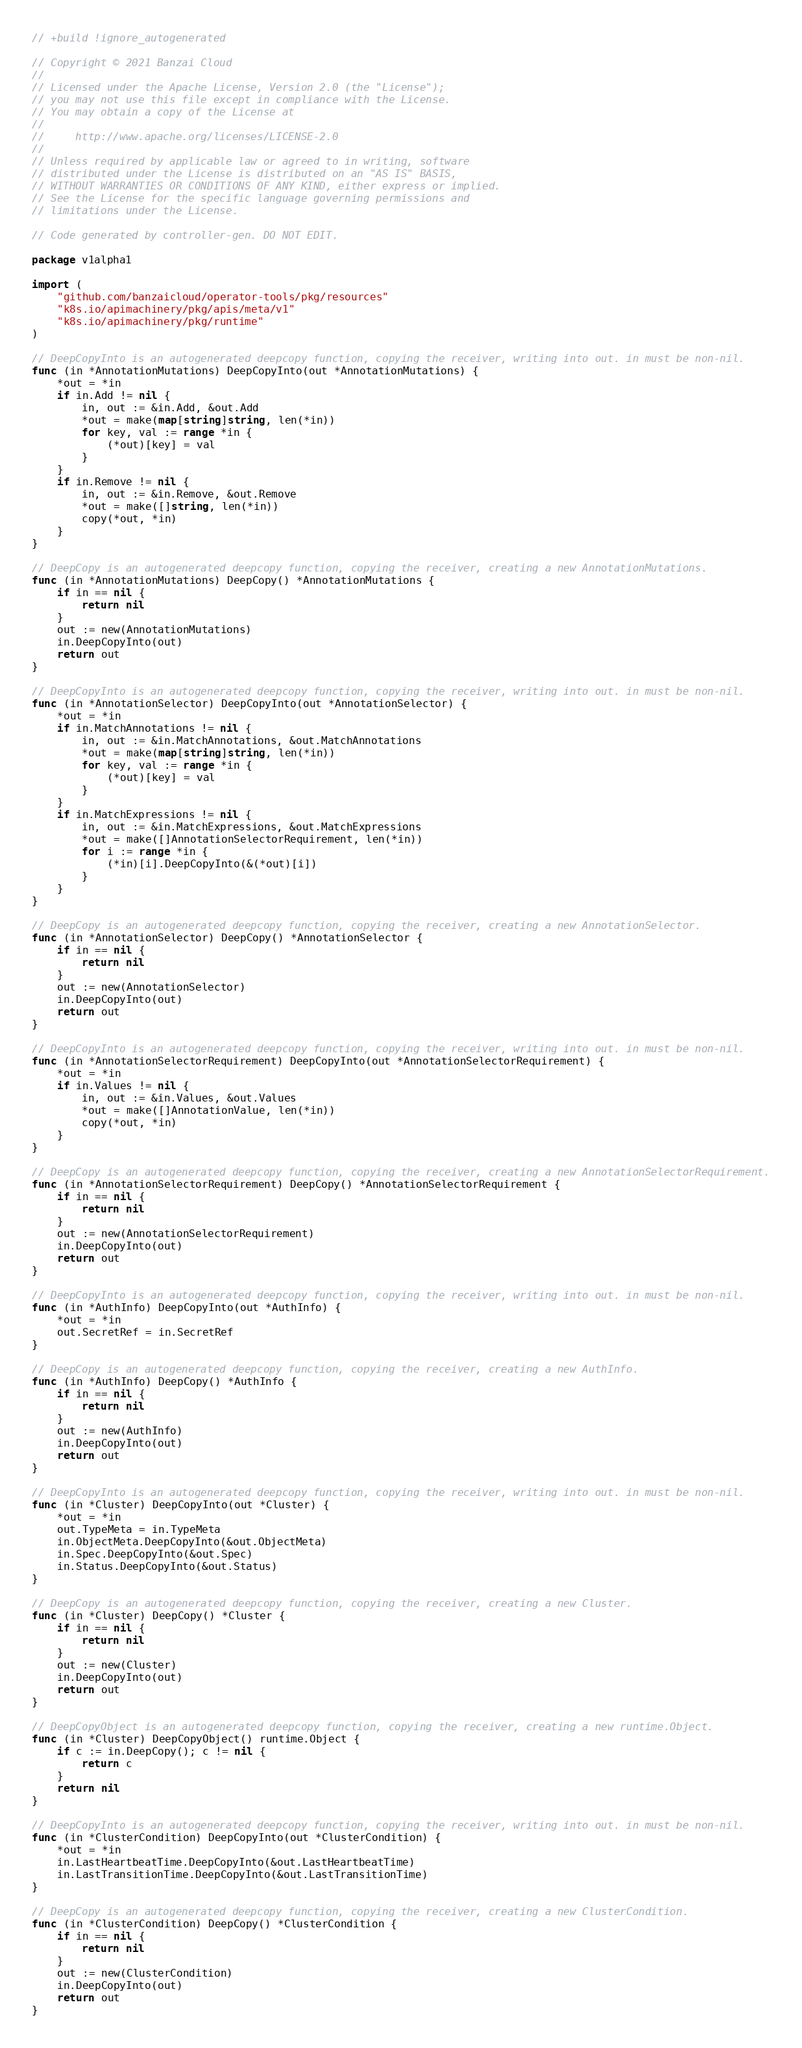Convert code to text. <code><loc_0><loc_0><loc_500><loc_500><_Go_>// +build !ignore_autogenerated

// Copyright © 2021 Banzai Cloud
//
// Licensed under the Apache License, Version 2.0 (the "License");
// you may not use this file except in compliance with the License.
// You may obtain a copy of the License at
//
//     http://www.apache.org/licenses/LICENSE-2.0
//
// Unless required by applicable law or agreed to in writing, software
// distributed under the License is distributed on an "AS IS" BASIS,
// WITHOUT WARRANTIES OR CONDITIONS OF ANY KIND, either express or implied.
// See the License for the specific language governing permissions and
// limitations under the License.

// Code generated by controller-gen. DO NOT EDIT.

package v1alpha1

import (
	"github.com/banzaicloud/operator-tools/pkg/resources"
	"k8s.io/apimachinery/pkg/apis/meta/v1"
	"k8s.io/apimachinery/pkg/runtime"
)

// DeepCopyInto is an autogenerated deepcopy function, copying the receiver, writing into out. in must be non-nil.
func (in *AnnotationMutations) DeepCopyInto(out *AnnotationMutations) {
	*out = *in
	if in.Add != nil {
		in, out := &in.Add, &out.Add
		*out = make(map[string]string, len(*in))
		for key, val := range *in {
			(*out)[key] = val
		}
	}
	if in.Remove != nil {
		in, out := &in.Remove, &out.Remove
		*out = make([]string, len(*in))
		copy(*out, *in)
	}
}

// DeepCopy is an autogenerated deepcopy function, copying the receiver, creating a new AnnotationMutations.
func (in *AnnotationMutations) DeepCopy() *AnnotationMutations {
	if in == nil {
		return nil
	}
	out := new(AnnotationMutations)
	in.DeepCopyInto(out)
	return out
}

// DeepCopyInto is an autogenerated deepcopy function, copying the receiver, writing into out. in must be non-nil.
func (in *AnnotationSelector) DeepCopyInto(out *AnnotationSelector) {
	*out = *in
	if in.MatchAnnotations != nil {
		in, out := &in.MatchAnnotations, &out.MatchAnnotations
		*out = make(map[string]string, len(*in))
		for key, val := range *in {
			(*out)[key] = val
		}
	}
	if in.MatchExpressions != nil {
		in, out := &in.MatchExpressions, &out.MatchExpressions
		*out = make([]AnnotationSelectorRequirement, len(*in))
		for i := range *in {
			(*in)[i].DeepCopyInto(&(*out)[i])
		}
	}
}

// DeepCopy is an autogenerated deepcopy function, copying the receiver, creating a new AnnotationSelector.
func (in *AnnotationSelector) DeepCopy() *AnnotationSelector {
	if in == nil {
		return nil
	}
	out := new(AnnotationSelector)
	in.DeepCopyInto(out)
	return out
}

// DeepCopyInto is an autogenerated deepcopy function, copying the receiver, writing into out. in must be non-nil.
func (in *AnnotationSelectorRequirement) DeepCopyInto(out *AnnotationSelectorRequirement) {
	*out = *in
	if in.Values != nil {
		in, out := &in.Values, &out.Values
		*out = make([]AnnotationValue, len(*in))
		copy(*out, *in)
	}
}

// DeepCopy is an autogenerated deepcopy function, copying the receiver, creating a new AnnotationSelectorRequirement.
func (in *AnnotationSelectorRequirement) DeepCopy() *AnnotationSelectorRequirement {
	if in == nil {
		return nil
	}
	out := new(AnnotationSelectorRequirement)
	in.DeepCopyInto(out)
	return out
}

// DeepCopyInto is an autogenerated deepcopy function, copying the receiver, writing into out. in must be non-nil.
func (in *AuthInfo) DeepCopyInto(out *AuthInfo) {
	*out = *in
	out.SecretRef = in.SecretRef
}

// DeepCopy is an autogenerated deepcopy function, copying the receiver, creating a new AuthInfo.
func (in *AuthInfo) DeepCopy() *AuthInfo {
	if in == nil {
		return nil
	}
	out := new(AuthInfo)
	in.DeepCopyInto(out)
	return out
}

// DeepCopyInto is an autogenerated deepcopy function, copying the receiver, writing into out. in must be non-nil.
func (in *Cluster) DeepCopyInto(out *Cluster) {
	*out = *in
	out.TypeMeta = in.TypeMeta
	in.ObjectMeta.DeepCopyInto(&out.ObjectMeta)
	in.Spec.DeepCopyInto(&out.Spec)
	in.Status.DeepCopyInto(&out.Status)
}

// DeepCopy is an autogenerated deepcopy function, copying the receiver, creating a new Cluster.
func (in *Cluster) DeepCopy() *Cluster {
	if in == nil {
		return nil
	}
	out := new(Cluster)
	in.DeepCopyInto(out)
	return out
}

// DeepCopyObject is an autogenerated deepcopy function, copying the receiver, creating a new runtime.Object.
func (in *Cluster) DeepCopyObject() runtime.Object {
	if c := in.DeepCopy(); c != nil {
		return c
	}
	return nil
}

// DeepCopyInto is an autogenerated deepcopy function, copying the receiver, writing into out. in must be non-nil.
func (in *ClusterCondition) DeepCopyInto(out *ClusterCondition) {
	*out = *in
	in.LastHeartbeatTime.DeepCopyInto(&out.LastHeartbeatTime)
	in.LastTransitionTime.DeepCopyInto(&out.LastTransitionTime)
}

// DeepCopy is an autogenerated deepcopy function, copying the receiver, creating a new ClusterCondition.
func (in *ClusterCondition) DeepCopy() *ClusterCondition {
	if in == nil {
		return nil
	}
	out := new(ClusterCondition)
	in.DeepCopyInto(out)
	return out
}
</code> 